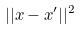<formula> <loc_0><loc_0><loc_500><loc_500>| | x - x ^ { \prime } | | ^ { 2 }</formula> 